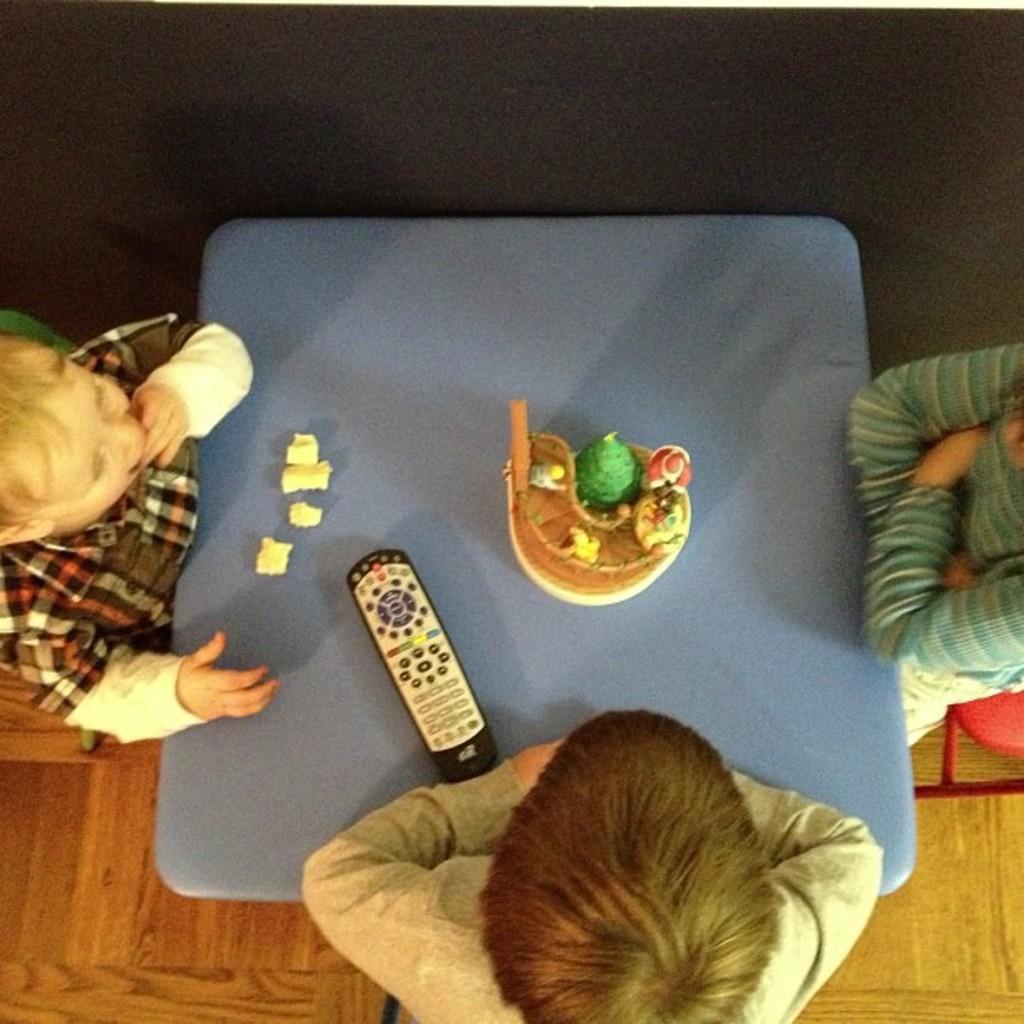In one or two sentences, can you explain what this image depicts? In this image I can see on the left side a boy is sitting on the chair and eating. At the bottom a person is sitting, keeping hands on the table. In the middle there is a remote and playing items and where it looks like a cake. On the right side a woman is sitting, she wore sweater. 